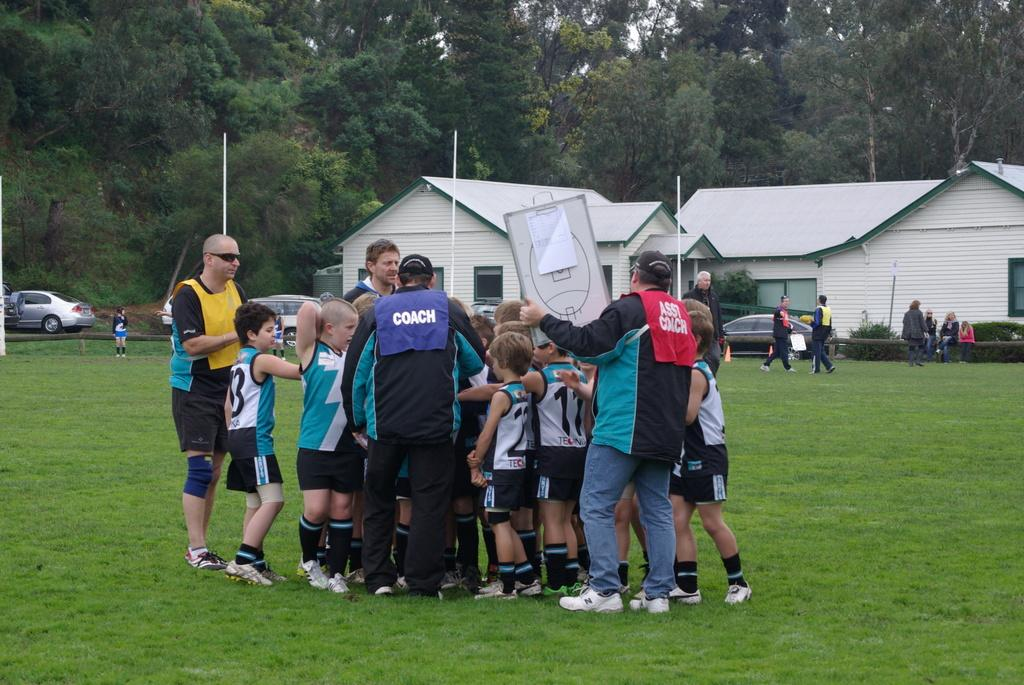What are the people in the image doing? The people in the image are standing on the grass in the center of the image. What can be seen in the background of the image? There are houses and trees in the background of the image. What else is present in the image besides the people and background? There are vehicles in the image. How many flames can be seen on the stage in the image? There is no stage or people present in the image, so there are no flames to count. 